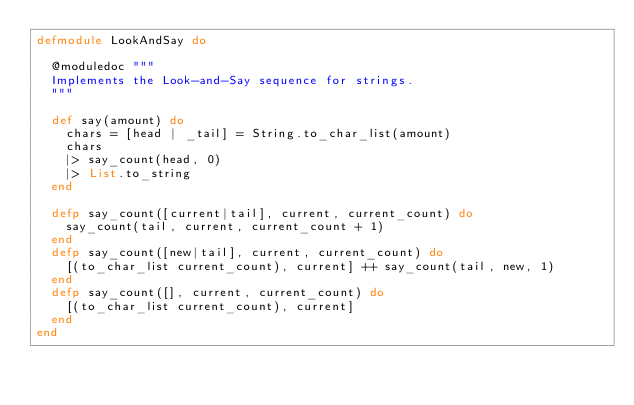Convert code to text. <code><loc_0><loc_0><loc_500><loc_500><_Elixir_>defmodule LookAndSay do

  @moduledoc """
  Implements the Look-and-Say sequence for strings.
  """

  def say(amount) do
    chars = [head | _tail] = String.to_char_list(amount)
    chars
    |> say_count(head, 0)
    |> List.to_string
  end

  defp say_count([current|tail], current, current_count) do
    say_count(tail, current, current_count + 1)
  end
  defp say_count([new|tail], current, current_count) do
    [(to_char_list current_count), current] ++ say_count(tail, new, 1)
  end
  defp say_count([], current, current_count) do
    [(to_char_list current_count), current]
  end
end
</code> 